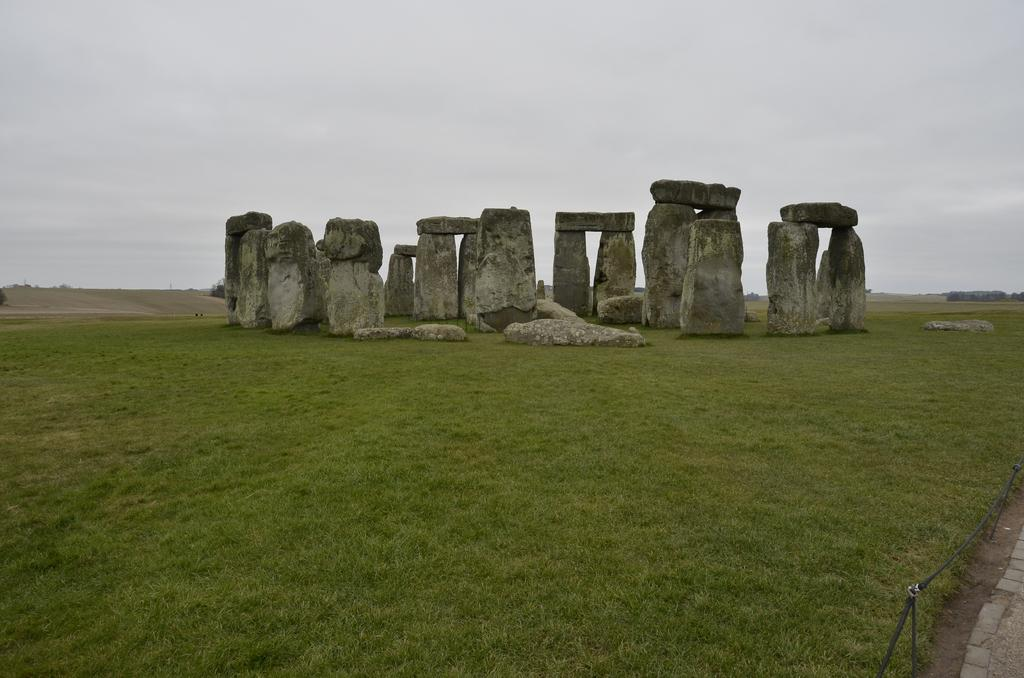What type of ground is visible in the image? The ground in the image is covered with grass. What can be seen in the middle of the image? There are rocks in the middle of the image, stacked one over the other. What is visible in the background of the image? The sky is visible in the background of the image. How many feet are visible in the image? There are no feet present in the image. What type of nose can be seen on the rocks in the image? There are no noses present on the rocks in the image. 